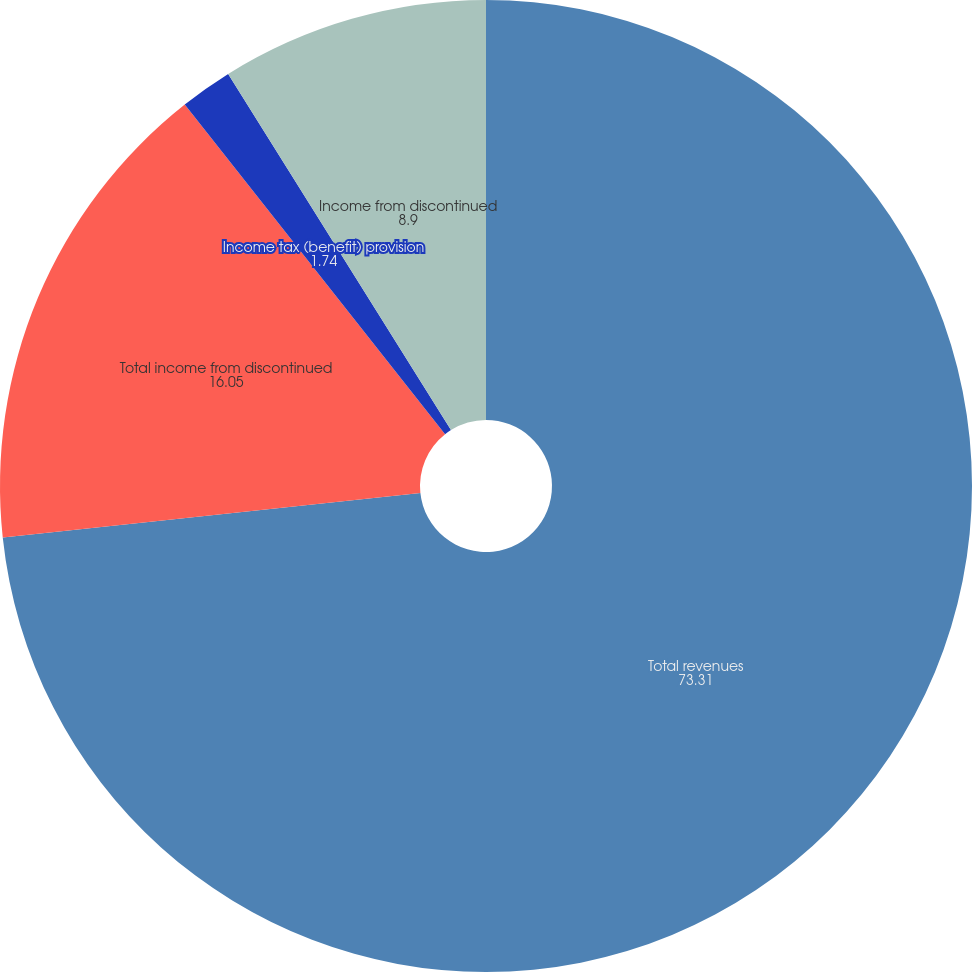<chart> <loc_0><loc_0><loc_500><loc_500><pie_chart><fcel>Total revenues<fcel>Total income from discontinued<fcel>Income tax (benefit) provision<fcel>Income from discontinued<nl><fcel>73.31%<fcel>16.05%<fcel>1.74%<fcel>8.9%<nl></chart> 